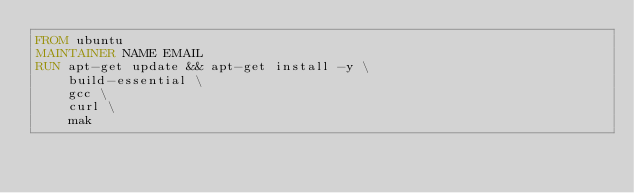Convert code to text. <code><loc_0><loc_0><loc_500><loc_500><_Dockerfile_>FROM ubuntu
MAINTAINER NAME EMAIL
RUN apt-get update && apt-get install -y \
    build-essential \
    gcc \
    curl \
    mak
</code> 